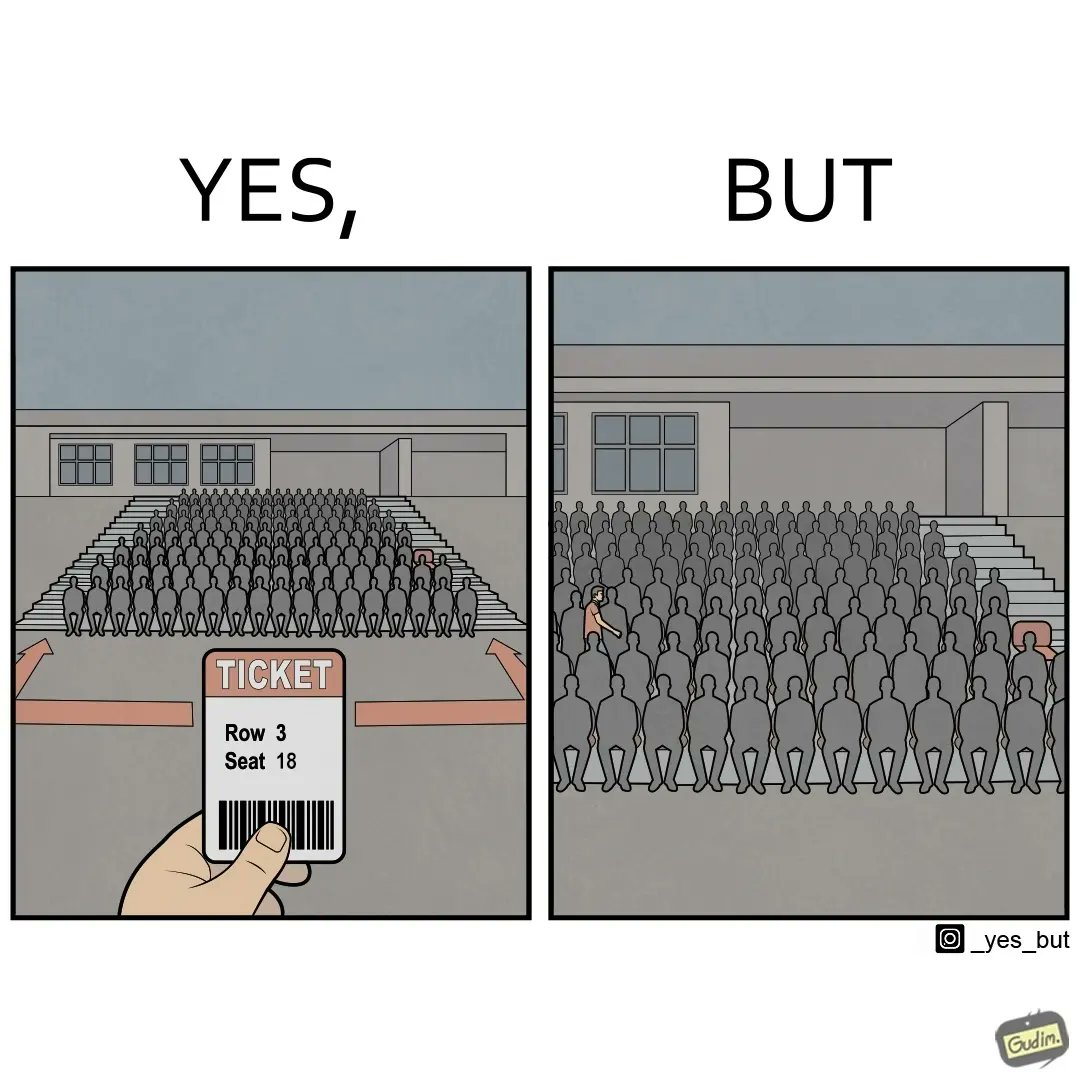Explain why this image is satirical. The image is funny, as the person has a ticket of a seat that is on the leftmost end of the gallery. However, the person has entered from the other end, and is going through a sea of seated people to get to the vacant seat. This would cause inconvenience to the people in the row, and would probably take a longer time to reach the seat. 